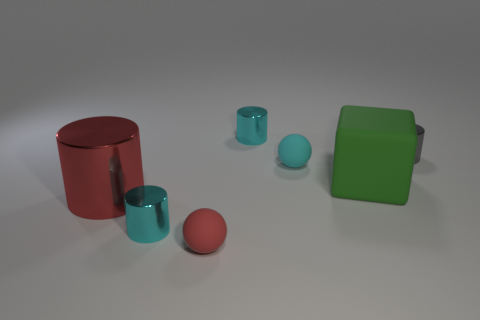Add 1 large blue metal objects. How many objects exist? 8 Subtract all cylinders. How many objects are left? 3 Add 4 big brown rubber objects. How many big brown rubber objects exist? 4 Subtract 0 green cylinders. How many objects are left? 7 Subtract all small gray metallic cylinders. Subtract all gray metal objects. How many objects are left? 5 Add 5 big green things. How many big green things are left? 6 